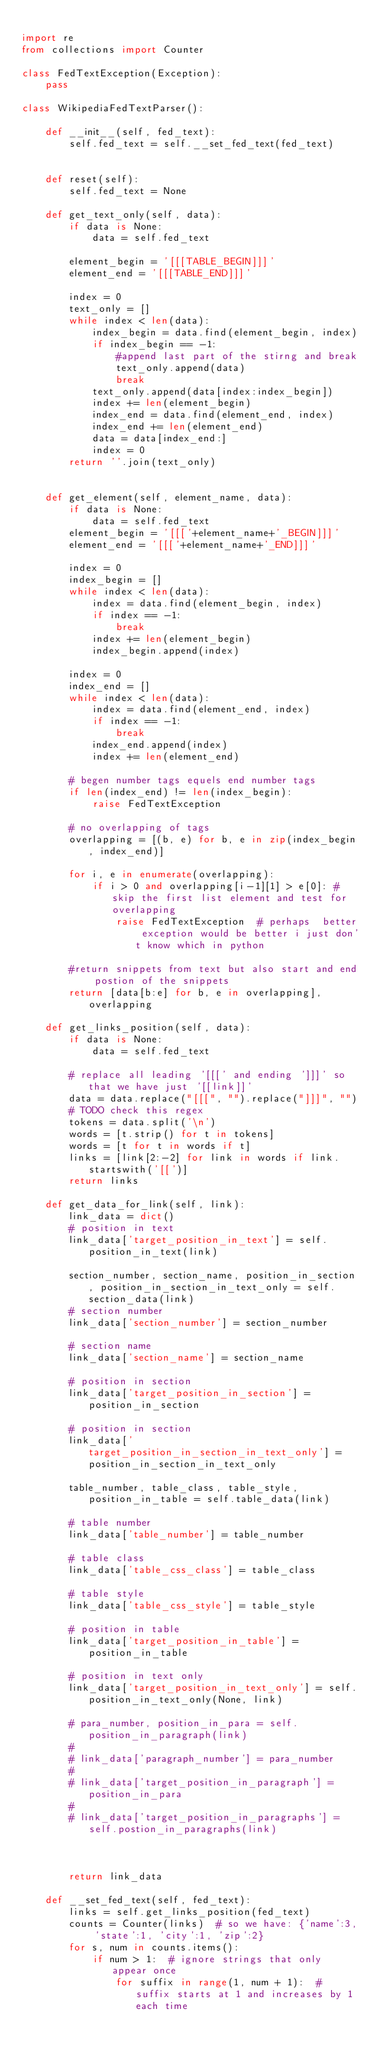Convert code to text. <code><loc_0><loc_0><loc_500><loc_500><_Python_>
import re
from collections import Counter

class FedTextException(Exception):
    pass

class WikipediaFedTextParser():

    def __init__(self, fed_text):
        self.fed_text = self.__set_fed_text(fed_text)


    def reset(self):
        self.fed_text = None

    def get_text_only(self, data):
        if data is None:
            data = self.fed_text

        element_begin = '[[[TABLE_BEGIN]]]'
        element_end = '[[[TABLE_END]]]'

        index = 0
        text_only = []
        while index < len(data):
            index_begin = data.find(element_begin, index)
            if index_begin == -1:
                #append last part of the stirng and break
                text_only.append(data)
                break
            text_only.append(data[index:index_begin])
            index += len(element_begin)
            index_end = data.find(element_end, index)
            index_end += len(element_end)
            data = data[index_end:]
            index = 0
        return ''.join(text_only)


    def get_element(self, element_name, data):
        if data is None:
            data = self.fed_text
        element_begin = '[[['+element_name+'_BEGIN]]]'
        element_end = '[[['+element_name+'_END]]]'

        index = 0
        index_begin = []
        while index < len(data):
            index = data.find(element_begin, index)
            if index == -1:
                break
            index += len(element_begin)
            index_begin.append(index)

        index = 0
        index_end = []
        while index < len(data):
            index = data.find(element_end, index)
            if index == -1:
                break
            index_end.append(index)
            index += len(element_end)

        # begen number tags equels end number tags
        if len(index_end) != len(index_begin):
            raise FedTextException

        # no overlapping of tags
        overlapping = [(b, e) for b, e in zip(index_begin, index_end)]

        for i, e in enumerate(overlapping):
            if i > 0 and overlapping[i-1][1] > e[0]: #skip the first list element and test for overlapping
                raise FedTextException  # perhaps  better exception would be better i just don't know which in python

        #return snippets from text but also start and end postion of the snippets
        return [data[b:e] for b, e in overlapping], overlapping

    def get_links_position(self, data):
        if data is None:
            data = self.fed_text

        # replace all leading '[[[' and ending ']]]' so that we have just '[[link]]'
        data = data.replace("[[[", "").replace("]]]", "")
        # TODO check this regex
        tokens = data.split('\n')
        words = [t.strip() for t in tokens]
        words = [t for t in words if t]
        links = [link[2:-2] for link in words if link.startswith('[[')]
        return links

    def get_data_for_link(self, link):
        link_data = dict()
        # position in text
        link_data['target_position_in_text'] = self.position_in_text(link)

        section_number, section_name, position_in_section, position_in_section_in_text_only = self.section_data(link)
        # section number
        link_data['section_number'] = section_number

        # section name
        link_data['section_name'] = section_name

        # position in section
        link_data['target_position_in_section'] = position_in_section
        
        # position in section
        link_data['target_position_in_section_in_text_only'] = position_in_section_in_text_only

        table_number, table_class, table_style, position_in_table = self.table_data(link)

        # table number
        link_data['table_number'] = table_number

        # table class
        link_data['table_css_class'] = table_class

        # table style
        link_data['table_css_style'] = table_style

        # position in table
        link_data['target_position_in_table'] = position_in_table

        # position in text only
        link_data['target_position_in_text_only'] = self.position_in_text_only(None, link)

        # para_number, position_in_para = self.position_in_paragraph(link)
        #
        # link_data['paragraph_number'] = para_number
        #
        # link_data['target_position_in_paragraph'] = position_in_para
        #
        # link_data['target_position_in_paragraphs'] = self.postion_in_paragraphs(link)
        
        
        
        return link_data

    def __set_fed_text(self, fed_text):
        links = self.get_links_position(fed_text)
        counts = Counter(links)  # so we have: {'name':3, 'state':1, 'city':1, 'zip':2}
        for s, num in counts.items():
            if num > 1:  # ignore strings that only appear once
                for suffix in range(1, num + 1):  # suffix starts at 1 and increases by 1 each time</code> 